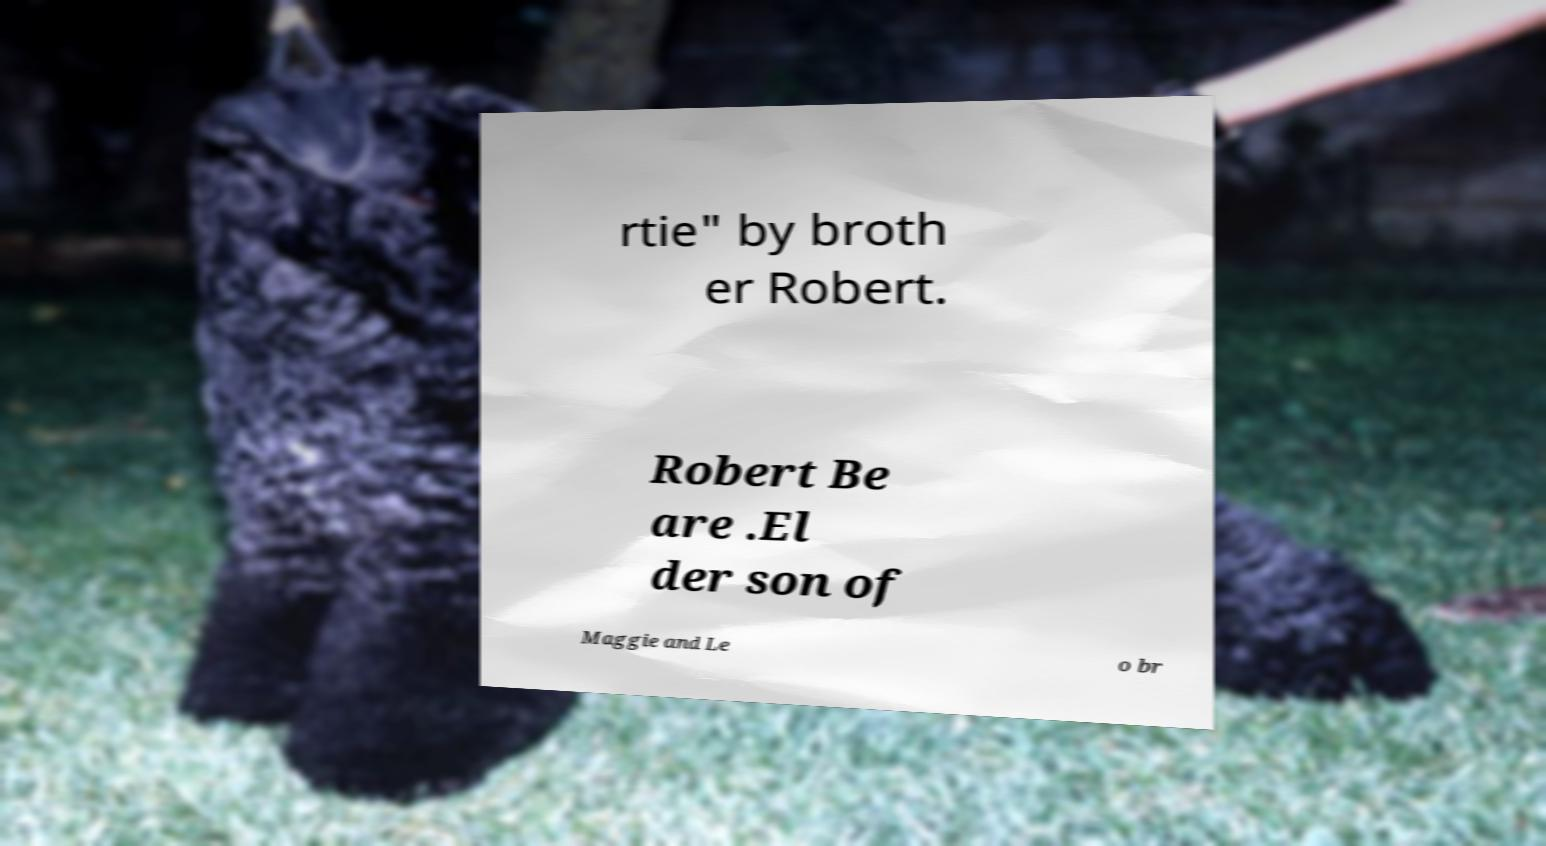Please read and relay the text visible in this image. What does it say? rtie" by broth er Robert. Robert Be are .El der son of Maggie and Le o br 